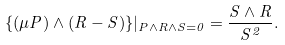<formula> <loc_0><loc_0><loc_500><loc_500>\{ ( \mu P ) \wedge ( R - S ) \} | _ { P \wedge R \wedge S = 0 } = \frac { S \wedge R } { S ^ { 2 } } .</formula> 